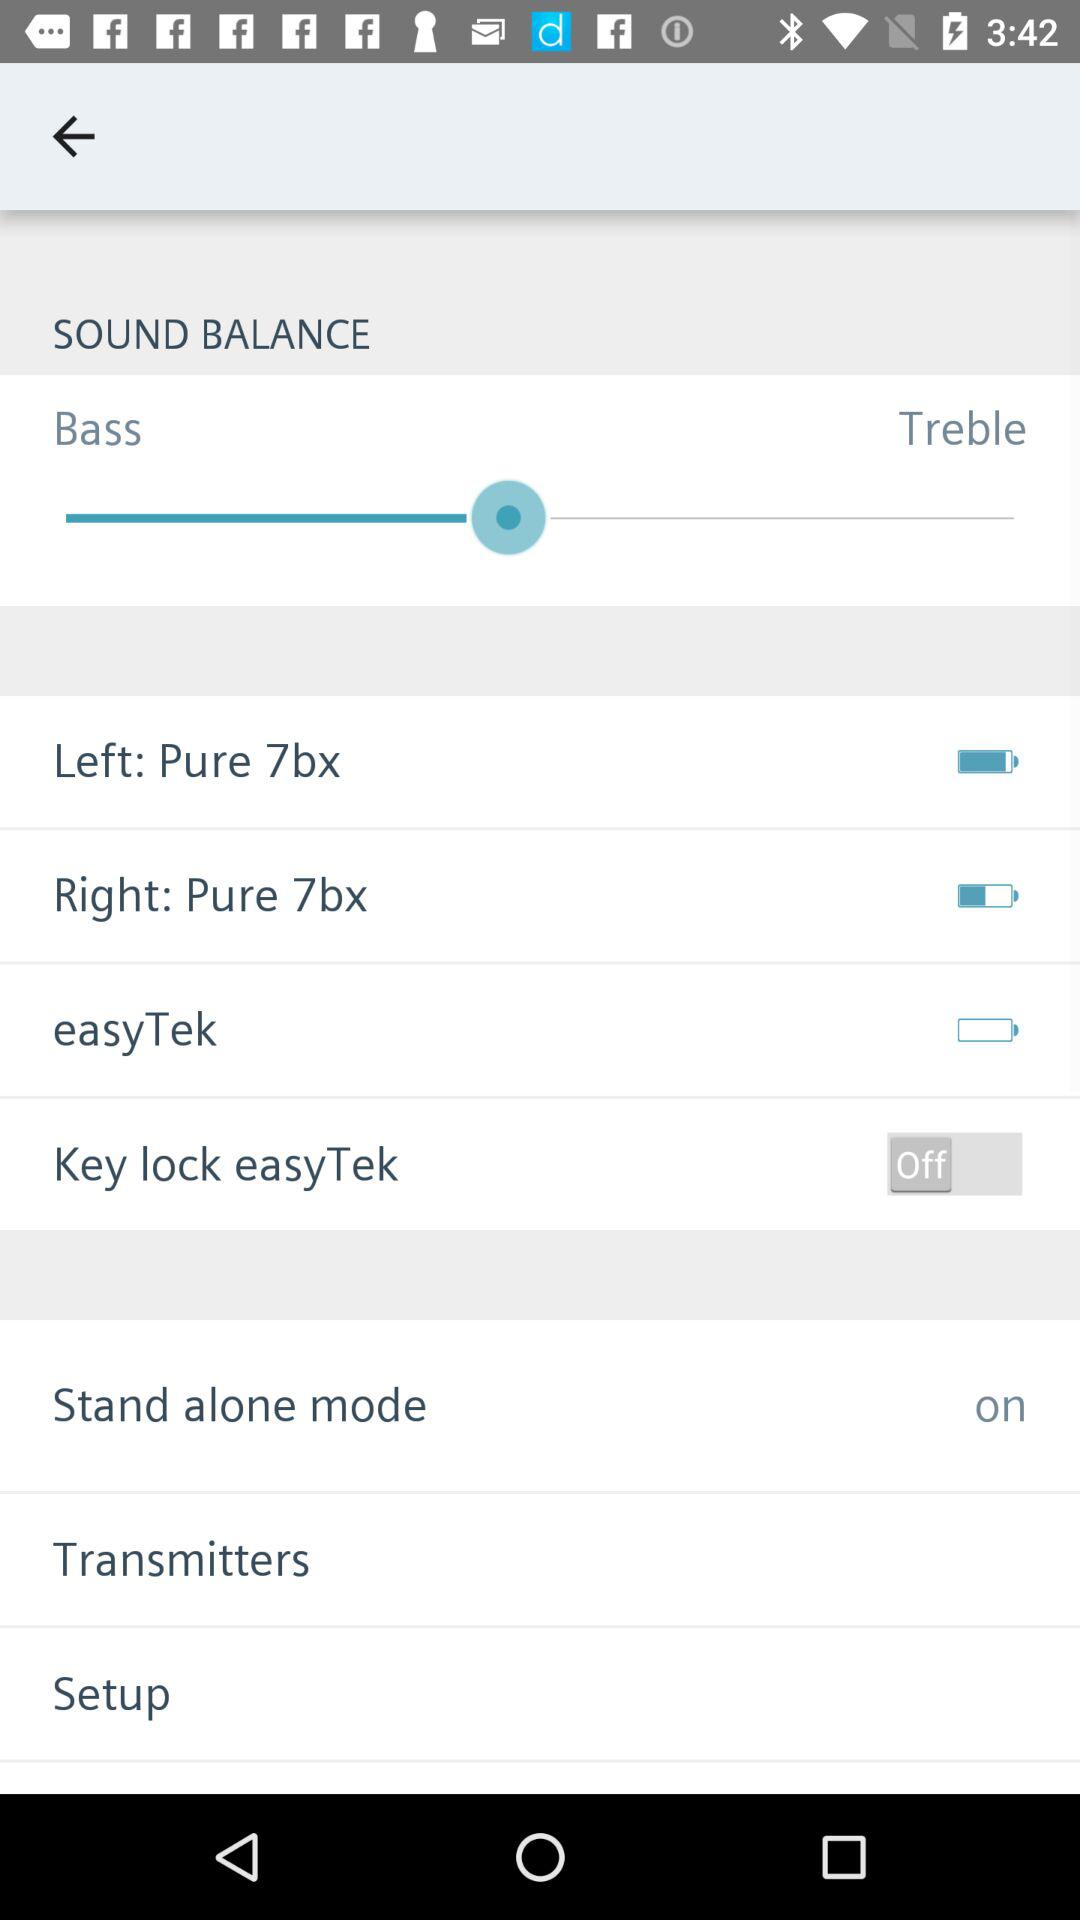What is the setting for the "Stand alone mode"? The setting for the "Stand alone mode" is "on". 